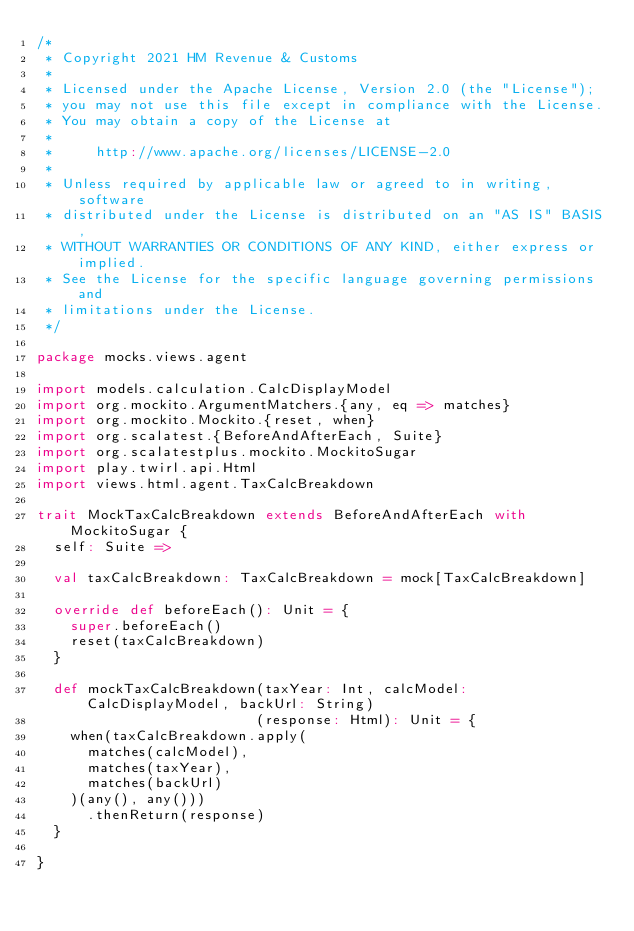<code> <loc_0><loc_0><loc_500><loc_500><_Scala_>/*
 * Copyright 2021 HM Revenue & Customs
 *
 * Licensed under the Apache License, Version 2.0 (the "License");
 * you may not use this file except in compliance with the License.
 * You may obtain a copy of the License at
 *
 *     http://www.apache.org/licenses/LICENSE-2.0
 *
 * Unless required by applicable law or agreed to in writing, software
 * distributed under the License is distributed on an "AS IS" BASIS,
 * WITHOUT WARRANTIES OR CONDITIONS OF ANY KIND, either express or implied.
 * See the License for the specific language governing permissions and
 * limitations under the License.
 */

package mocks.views.agent

import models.calculation.CalcDisplayModel
import org.mockito.ArgumentMatchers.{any, eq => matches}
import org.mockito.Mockito.{reset, when}
import org.scalatest.{BeforeAndAfterEach, Suite}
import org.scalatestplus.mockito.MockitoSugar
import play.twirl.api.Html
import views.html.agent.TaxCalcBreakdown

trait MockTaxCalcBreakdown extends BeforeAndAfterEach with MockitoSugar {
  self: Suite =>

  val taxCalcBreakdown: TaxCalcBreakdown = mock[TaxCalcBreakdown]

  override def beforeEach(): Unit = {
    super.beforeEach()
    reset(taxCalcBreakdown)
  }

  def mockTaxCalcBreakdown(taxYear: Int, calcModel: CalcDisplayModel, backUrl: String)
                          (response: Html): Unit = {
    when(taxCalcBreakdown.apply(
      matches(calcModel),
      matches(taxYear),
      matches(backUrl)
    )(any(), any()))
      .thenReturn(response)
  }

}
</code> 